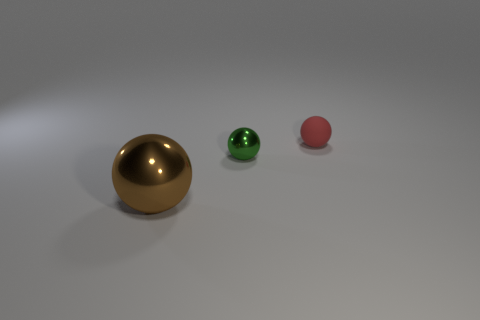Are there any other things that have the same size as the brown metal ball?
Give a very brief answer. No. There is a metal thing behind the brown sphere that is in front of the metal sphere to the right of the big shiny ball; what shape is it?
Your answer should be compact. Sphere. What shape is the thing that is both behind the big brown metal ball and in front of the red matte ball?
Your answer should be compact. Sphere. Is there a small thing made of the same material as the big brown ball?
Give a very brief answer. Yes. There is a shiny thing that is behind the brown shiny object; what is its color?
Ensure brevity in your answer.  Green. There is a tiny matte object; is its shape the same as the small object that is to the left of the red object?
Give a very brief answer. Yes. There is a sphere that is the same material as the tiny green object; what is its size?
Your response must be concise. Large. There is a metal thing that is behind the big sphere; is it the same shape as the brown thing?
Your answer should be compact. Yes. What number of objects have the same size as the red rubber sphere?
Offer a terse response. 1. There is a sphere in front of the small green object; is there a small rubber object in front of it?
Your response must be concise. No. 